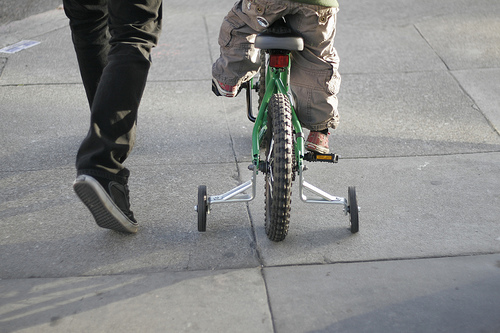<image>
Is the tire in front of the seat? No. The tire is not in front of the seat. The spatial positioning shows a different relationship between these objects. 